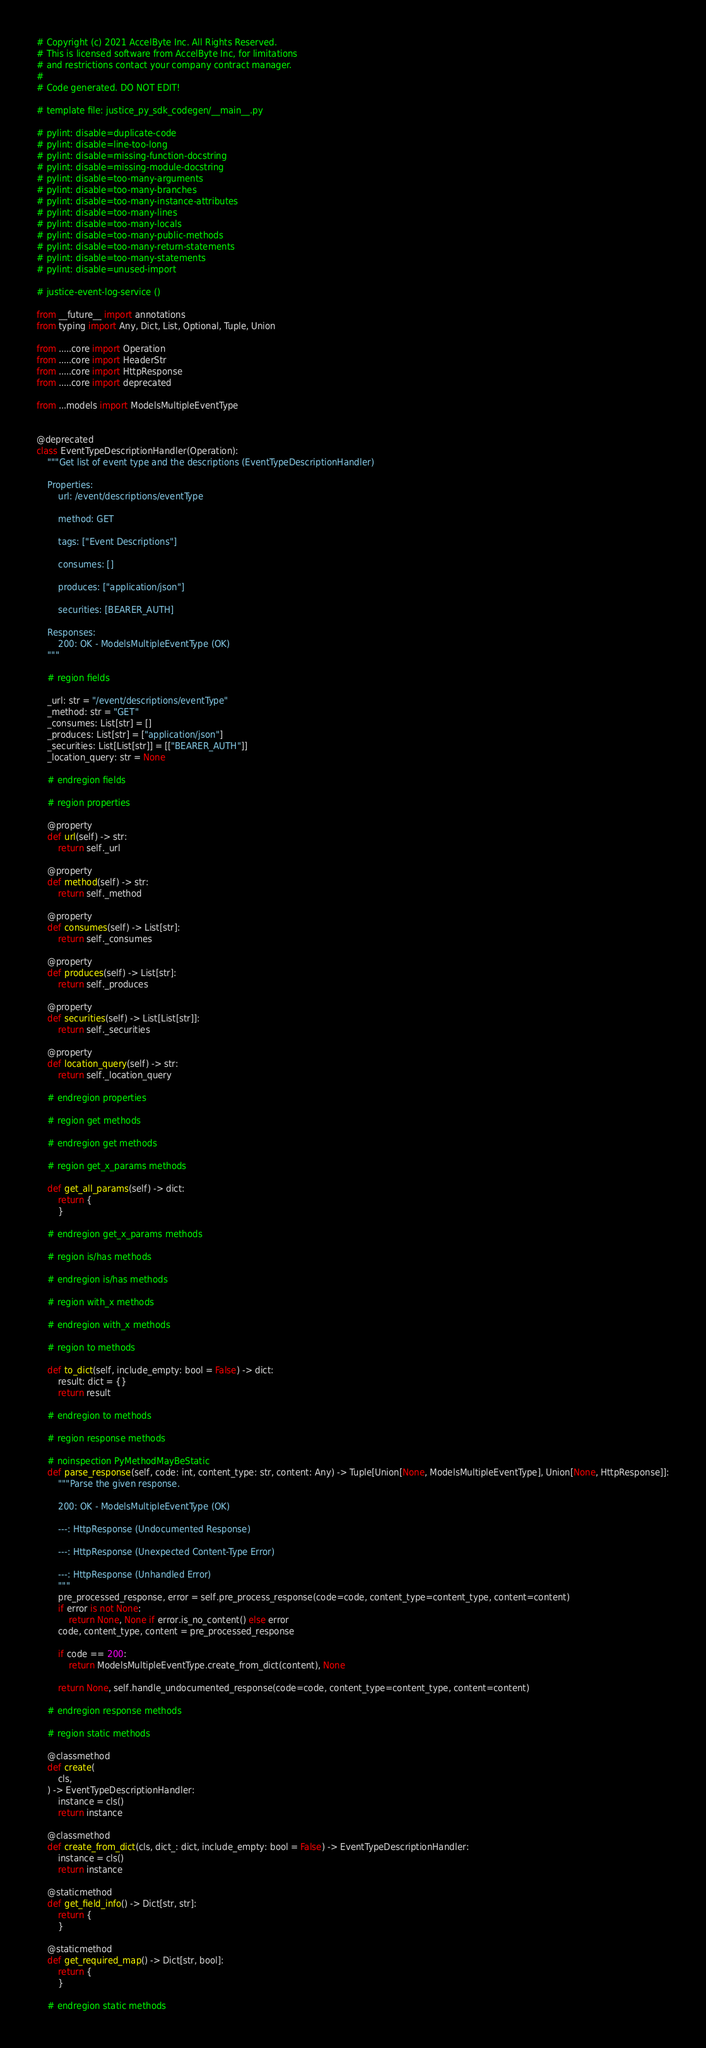Convert code to text. <code><loc_0><loc_0><loc_500><loc_500><_Python_># Copyright (c) 2021 AccelByte Inc. All Rights Reserved.
# This is licensed software from AccelByte Inc, for limitations
# and restrictions contact your company contract manager.
# 
# Code generated. DO NOT EDIT!

# template file: justice_py_sdk_codegen/__main__.py

# pylint: disable=duplicate-code
# pylint: disable=line-too-long
# pylint: disable=missing-function-docstring
# pylint: disable=missing-module-docstring
# pylint: disable=too-many-arguments
# pylint: disable=too-many-branches
# pylint: disable=too-many-instance-attributes
# pylint: disable=too-many-lines
# pylint: disable=too-many-locals
# pylint: disable=too-many-public-methods
# pylint: disable=too-many-return-statements
# pylint: disable=too-many-statements
# pylint: disable=unused-import

# justice-event-log-service ()

from __future__ import annotations
from typing import Any, Dict, List, Optional, Tuple, Union

from .....core import Operation
from .....core import HeaderStr
from .....core import HttpResponse
from .....core import deprecated

from ...models import ModelsMultipleEventType


@deprecated
class EventTypeDescriptionHandler(Operation):
    """Get list of event type and the descriptions (EventTypeDescriptionHandler)

    Properties:
        url: /event/descriptions/eventType

        method: GET

        tags: ["Event Descriptions"]

        consumes: []

        produces: ["application/json"]

        securities: [BEARER_AUTH]

    Responses:
        200: OK - ModelsMultipleEventType (OK)
    """

    # region fields

    _url: str = "/event/descriptions/eventType"
    _method: str = "GET"
    _consumes: List[str] = []
    _produces: List[str] = ["application/json"]
    _securities: List[List[str]] = [["BEARER_AUTH"]]
    _location_query: str = None

    # endregion fields

    # region properties

    @property
    def url(self) -> str:
        return self._url

    @property
    def method(self) -> str:
        return self._method

    @property
    def consumes(self) -> List[str]:
        return self._consumes

    @property
    def produces(self) -> List[str]:
        return self._produces

    @property
    def securities(self) -> List[List[str]]:
        return self._securities

    @property
    def location_query(self) -> str:
        return self._location_query

    # endregion properties

    # region get methods

    # endregion get methods

    # region get_x_params methods

    def get_all_params(self) -> dict:
        return {
        }

    # endregion get_x_params methods

    # region is/has methods

    # endregion is/has methods

    # region with_x methods

    # endregion with_x methods

    # region to methods

    def to_dict(self, include_empty: bool = False) -> dict:
        result: dict = {}
        return result

    # endregion to methods

    # region response methods

    # noinspection PyMethodMayBeStatic
    def parse_response(self, code: int, content_type: str, content: Any) -> Tuple[Union[None, ModelsMultipleEventType], Union[None, HttpResponse]]:
        """Parse the given response.

        200: OK - ModelsMultipleEventType (OK)

        ---: HttpResponse (Undocumented Response)

        ---: HttpResponse (Unexpected Content-Type Error)

        ---: HttpResponse (Unhandled Error)
        """
        pre_processed_response, error = self.pre_process_response(code=code, content_type=content_type, content=content)
        if error is not None:
            return None, None if error.is_no_content() else error
        code, content_type, content = pre_processed_response

        if code == 200:
            return ModelsMultipleEventType.create_from_dict(content), None

        return None, self.handle_undocumented_response(code=code, content_type=content_type, content=content)

    # endregion response methods

    # region static methods

    @classmethod
    def create(
        cls,
    ) -> EventTypeDescriptionHandler:
        instance = cls()
        return instance

    @classmethod
    def create_from_dict(cls, dict_: dict, include_empty: bool = False) -> EventTypeDescriptionHandler:
        instance = cls()
        return instance

    @staticmethod
    def get_field_info() -> Dict[str, str]:
        return {
        }

    @staticmethod
    def get_required_map() -> Dict[str, bool]:
        return {
        }

    # endregion static methods
</code> 